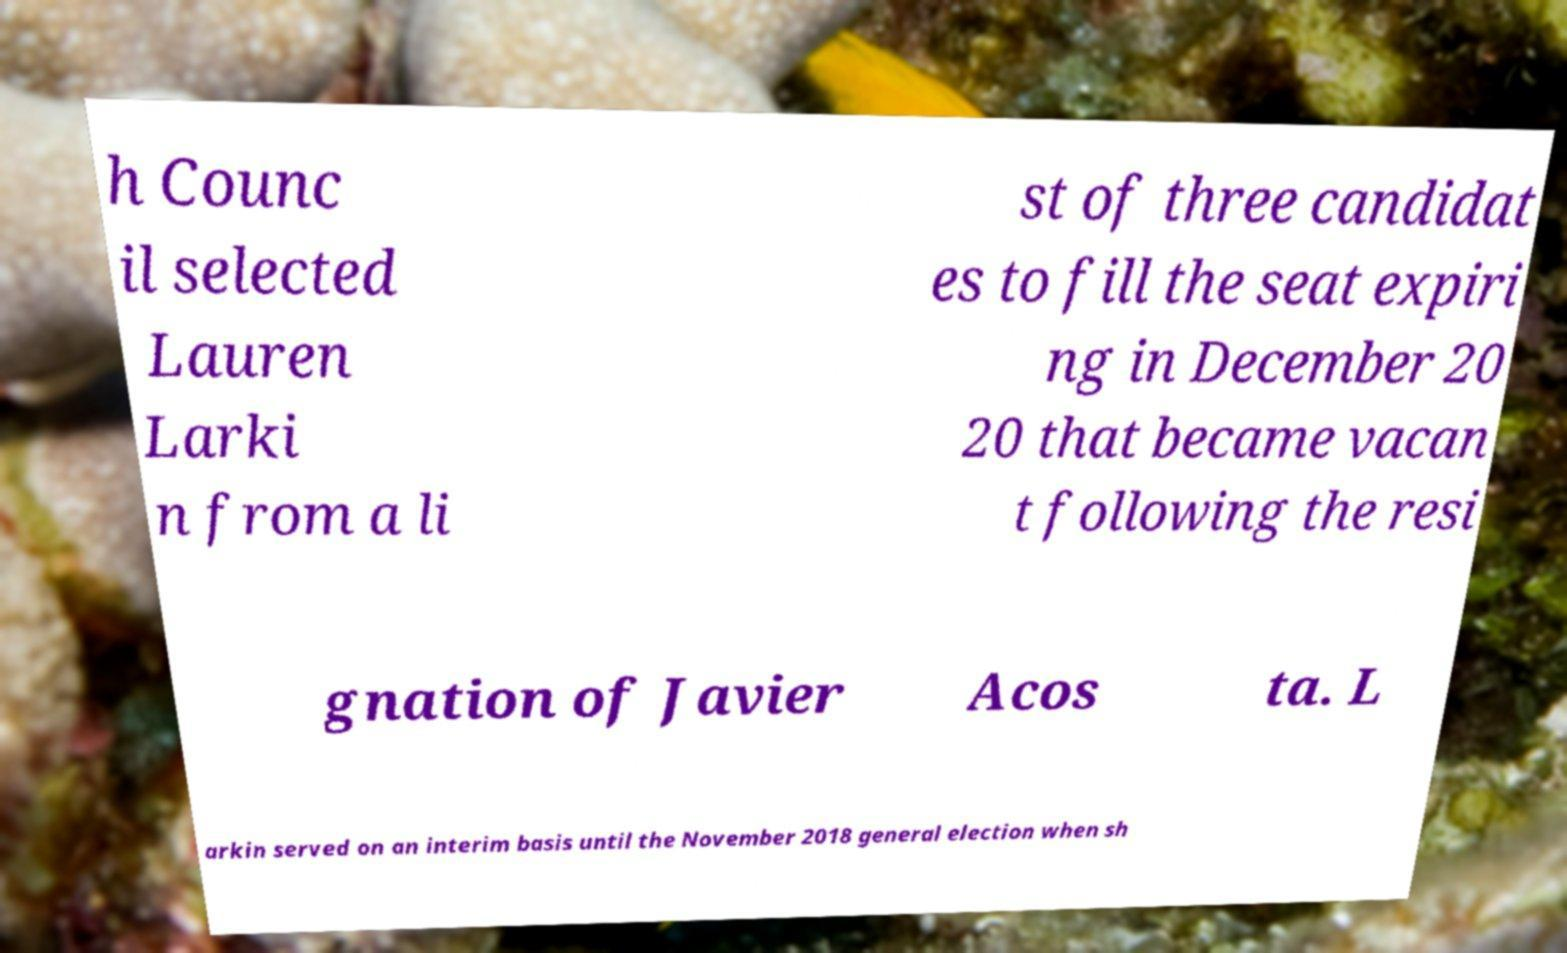Please read and relay the text visible in this image. What does it say? h Counc il selected Lauren Larki n from a li st of three candidat es to fill the seat expiri ng in December 20 20 that became vacan t following the resi gnation of Javier Acos ta. L arkin served on an interim basis until the November 2018 general election when sh 